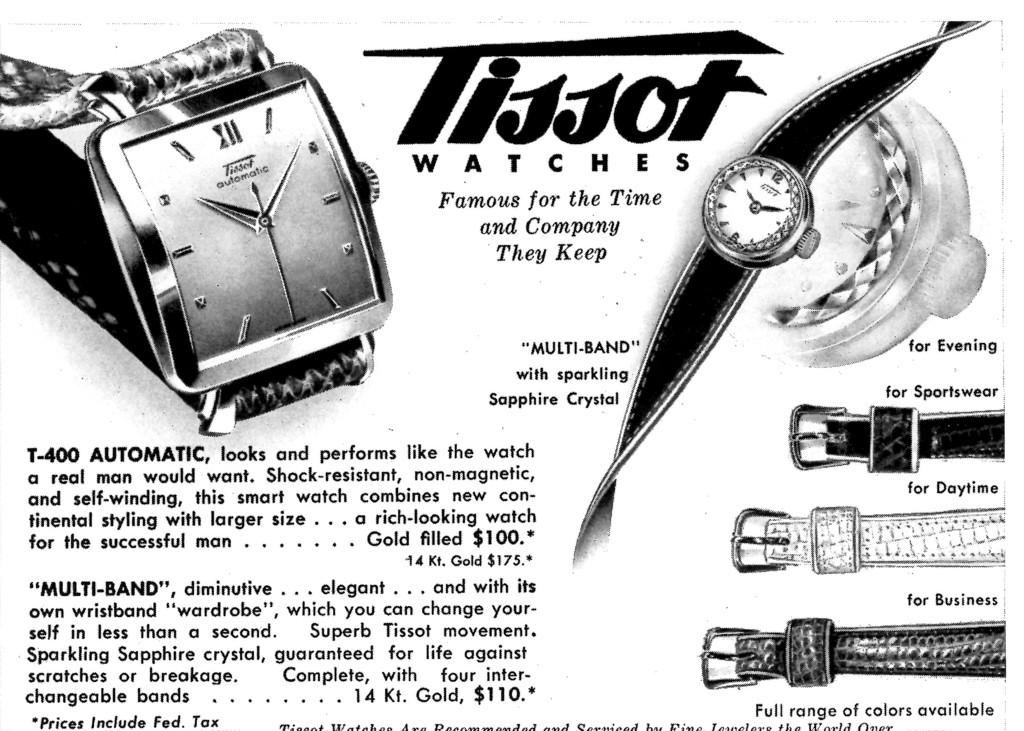<image>
Render a clear and concise summary of the photo. A black and white advertisement for Tissot watches 